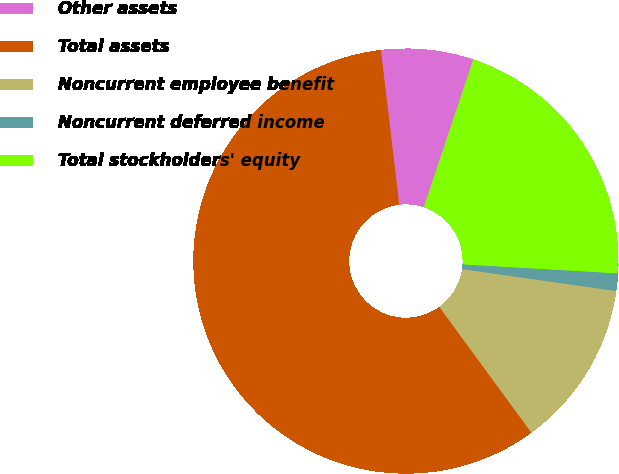Convert chart to OTSL. <chart><loc_0><loc_0><loc_500><loc_500><pie_chart><fcel>Other assets<fcel>Total assets<fcel>Noncurrent employee benefit<fcel>Noncurrent deferred income<fcel>Total stockholders' equity<nl><fcel>7.02%<fcel>58.17%<fcel>12.7%<fcel>1.33%<fcel>20.78%<nl></chart> 